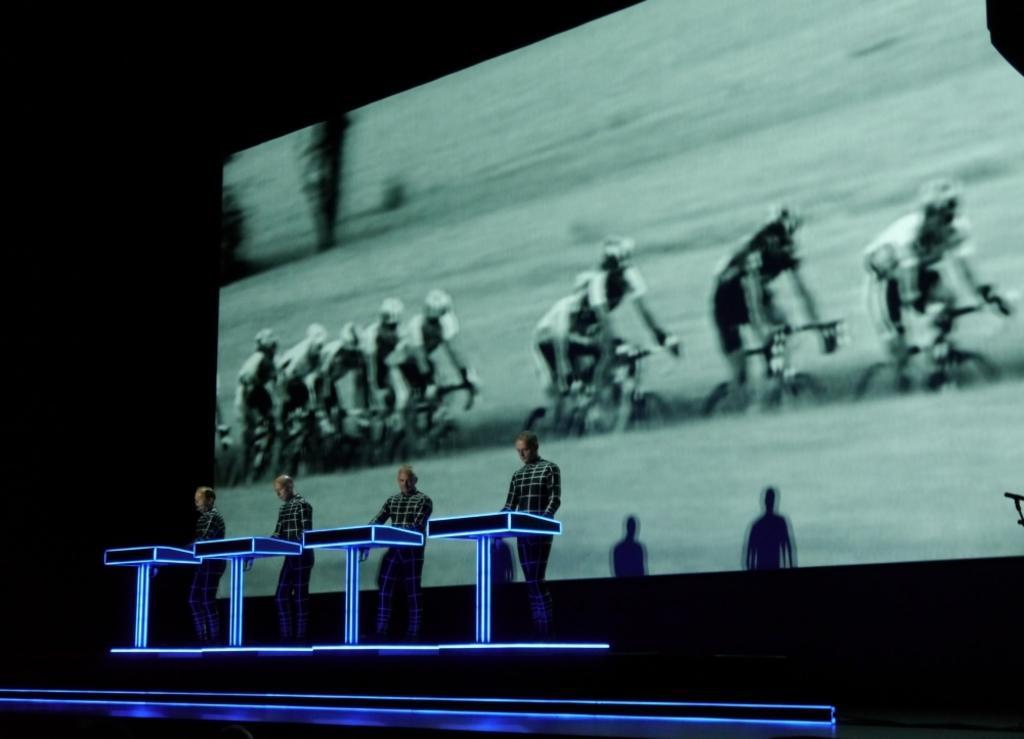In one or two sentences, can you explain what this image depicts? This picture is dark,there are four people standing,in front of these people we can see tables. In the background we can see screen and shadow of people,in this screen we can see people riding bicycles. 